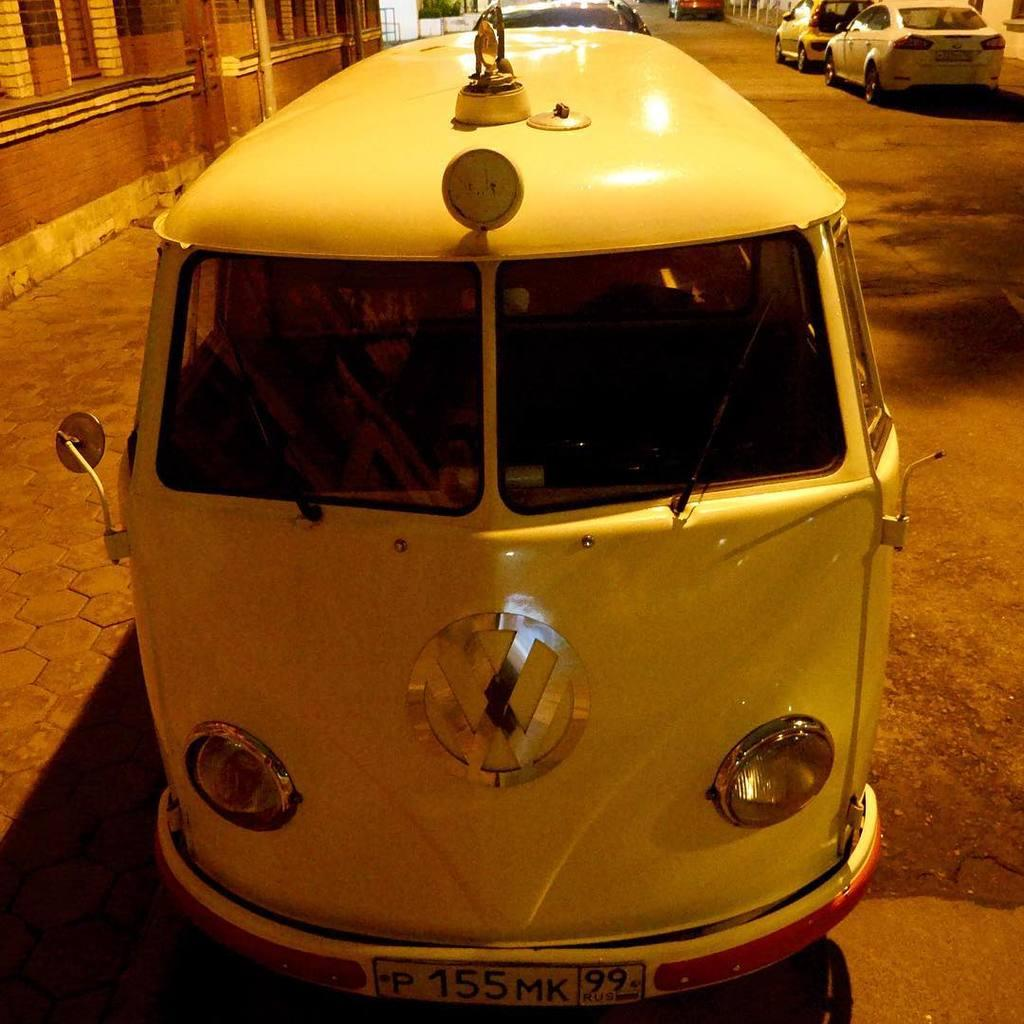What is the main subject of the image? The main subject of the image is a group of vehicles. Where are the vehicles located in the image? The vehicles are parked on the road. What can be seen on the left side of the image? There is a building on the left side of the image. How much money is being exchanged between the vehicles in the image? There is no indication of any money exchange in the image; it only shows parked vehicles and a building. 